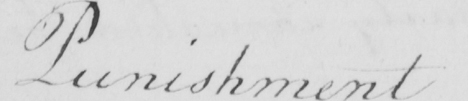Can you read and transcribe this handwriting? Punishment 